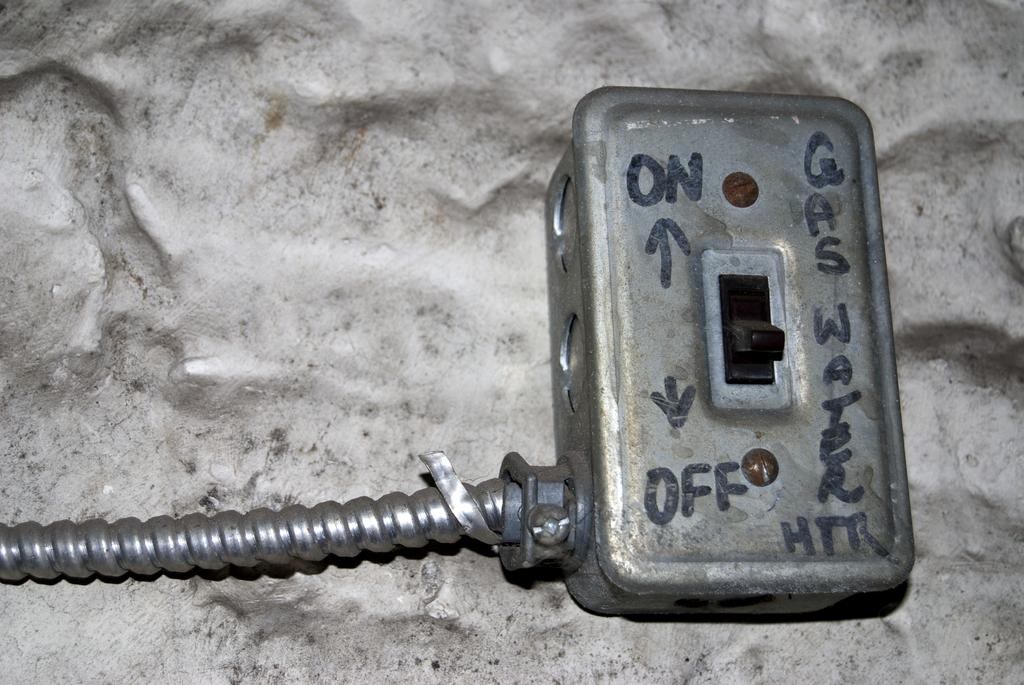Is on at the top or bottom?
Your answer should be compact. Top. 